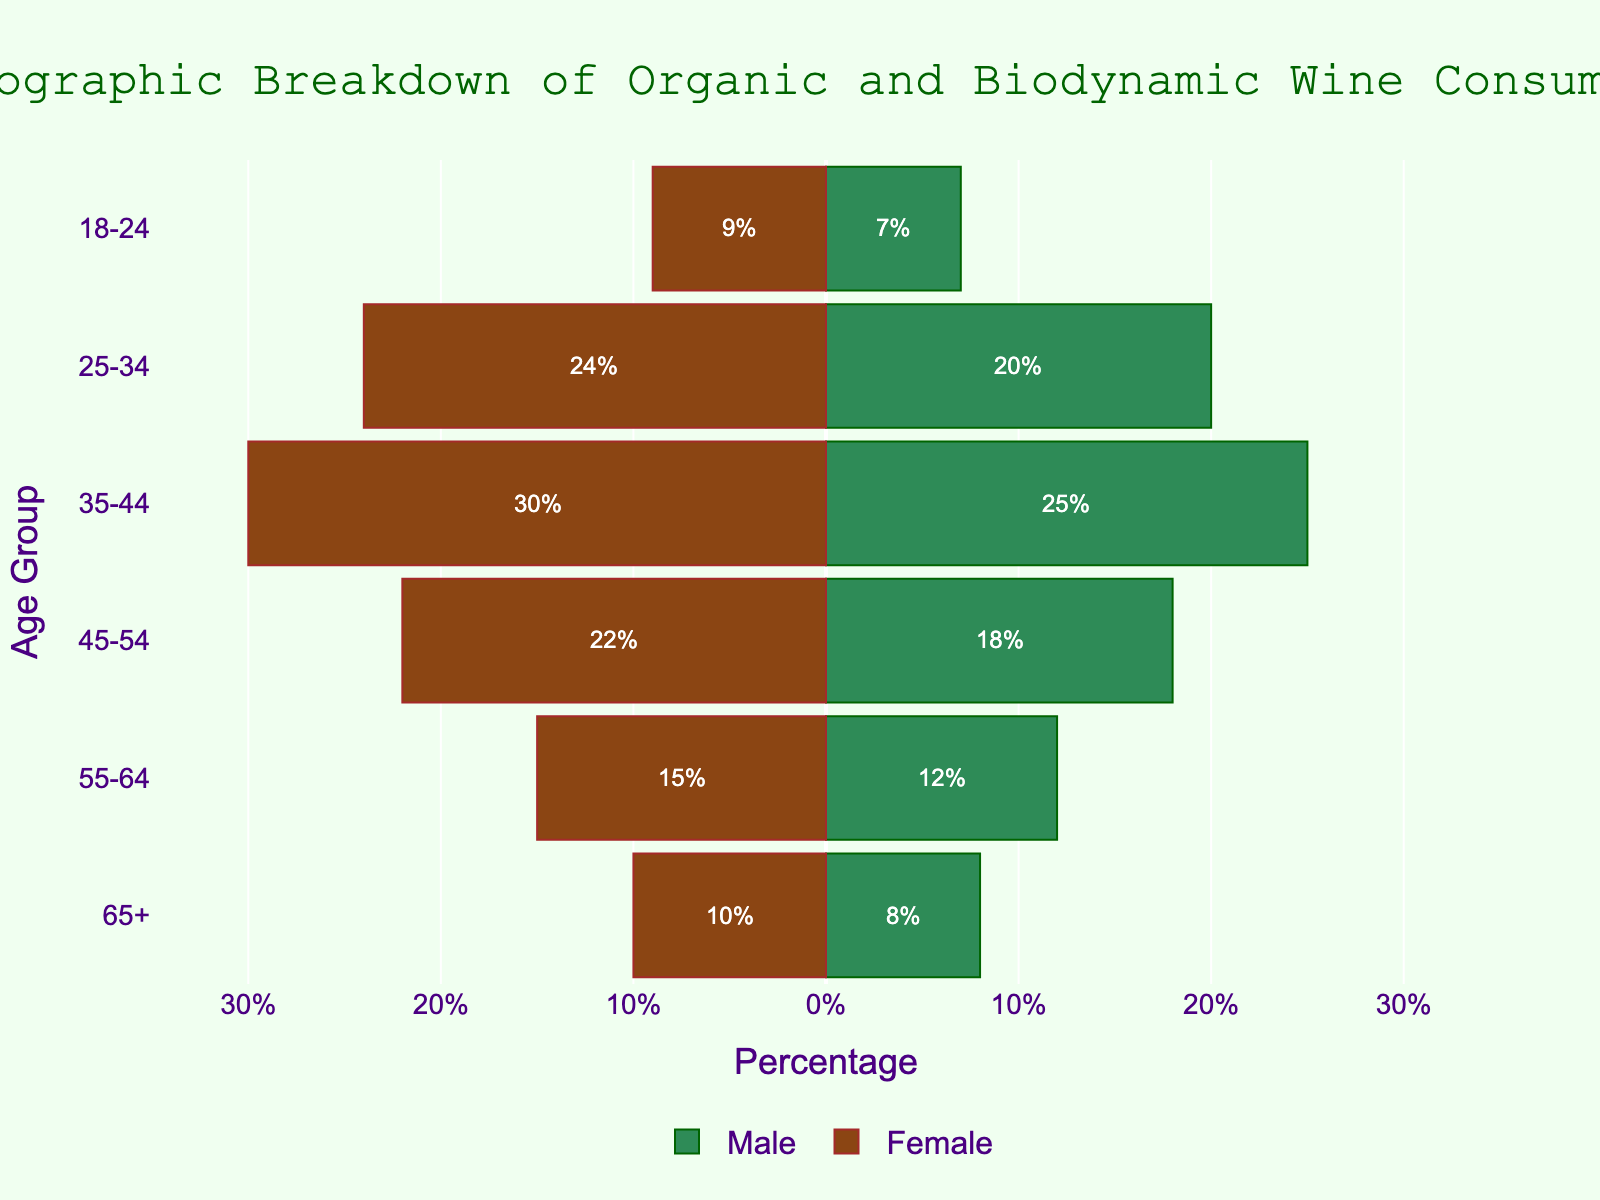What is the title of the figure? The title is prominently displayed at the top of the figure and reads "Demographic Breakdown of Organic and Biodynamic Wine Consumers".
Answer: Demographic Breakdown of Organic and Biodynamic Wine Consumers Which age group has the highest number of female consumers? By examining the negative bars on the right side of the pyramid, the age group '35-44' has the longest bar for females, indicating the highest number of female consumers.
Answer: 35-44 How many male consumers are in the age group 45-54? Locate the age group '45-54' on the left side of the pyramid, and observe the length of the bar which represents 18%.
Answer: 18 Compare the number of male and female consumers in the 25-34 age group. Which is higher and by how much? Male consumers are denoted by positive bars on the left and female consumers by negative bars on the right. For the age group 25-34, males are at 20% and females are at 24%. The difference is 24% - 20% = 4%.
Answer: Female by 4% What is the total percentage of consumers (male + female) in the age group 55-64? Add the percentage of male (12%) and female (15%) consumers for this age group. The total is 12% + 15% = 27%.
Answer: 27% Which age group has the smallest number of consumers for both genders? By comparing the lengths of the bars for each age group, '18-24' has the smallest combined bar lengths of 7% (male) and 9% (female), totaling 16%.
Answer: 18-24 Is there any age group where the number of male consumers is greater than female consumers? For each age group, compare the bars. Males are always represented on the left side with positive values, and females on the right with negative values. No age group has a male percentage higher than the female percentage.
Answer: No What percentage of consumers aged 65+ are female? On the right side of the pyramid, locate the bar for females in the '65+' age group, which is denoted as 10%.
Answer: 10% Which age group has the closest male and female consumer numbers and what are their respective percentages? By observing and comparing the lengths of the bars across all age groups, the '25-34' group has male (20%) and female (24%) consumers, which are the closest values.
Answer: 25-34: Male 20%, Female 24% What is the average percentage of male consumers across all age groups? Sum up the percentages: 8 + 12 + 18 + 25 + 20 + 7 = 90. Divide by the number of age groups (6): 90 / 6 = 15%.
Answer: 15% 